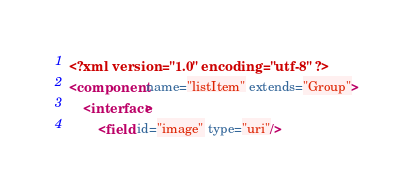Convert code to text. <code><loc_0><loc_0><loc_500><loc_500><_XML_><?xml version="1.0" encoding="utf-8" ?>
<component name="listItem" extends="Group">
    <interface>
        <field id="image" type="uri"/></code> 